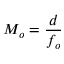<formula> <loc_0><loc_0><loc_500><loc_500>M _ { o } = { \frac { d } { f _ { o } } }</formula> 